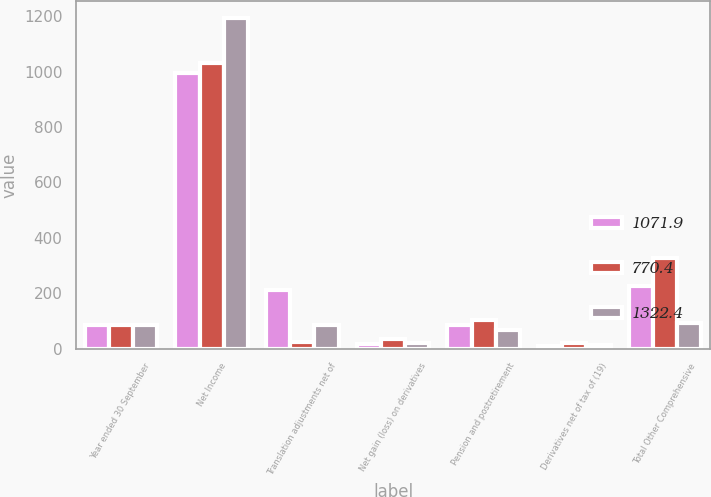Convert chart to OTSL. <chart><loc_0><loc_0><loc_500><loc_500><stacked_bar_chart><ecel><fcel>Year ended 30 September<fcel>Net Income<fcel>Translation adjustments net of<fcel>Net gain (loss) on derivatives<fcel>Pension and postretirement<fcel>Derivatives net of tax of (19)<fcel>Total Other Comprehensive<nl><fcel>1071.9<fcel>84.7<fcel>993.1<fcel>213.1<fcel>15.2<fcel>84.7<fcel>9.1<fcel>226.9<nl><fcel>770.4<fcel>84.7<fcel>1032.5<fcel>25<fcel>35<fcel>104.9<fcel>20.2<fcel>327.2<nl><fcel>1322.4<fcel>84.7<fcel>1193.3<fcel>84.6<fcel>21.8<fcel>67<fcel>12.4<fcel>90.5<nl></chart> 